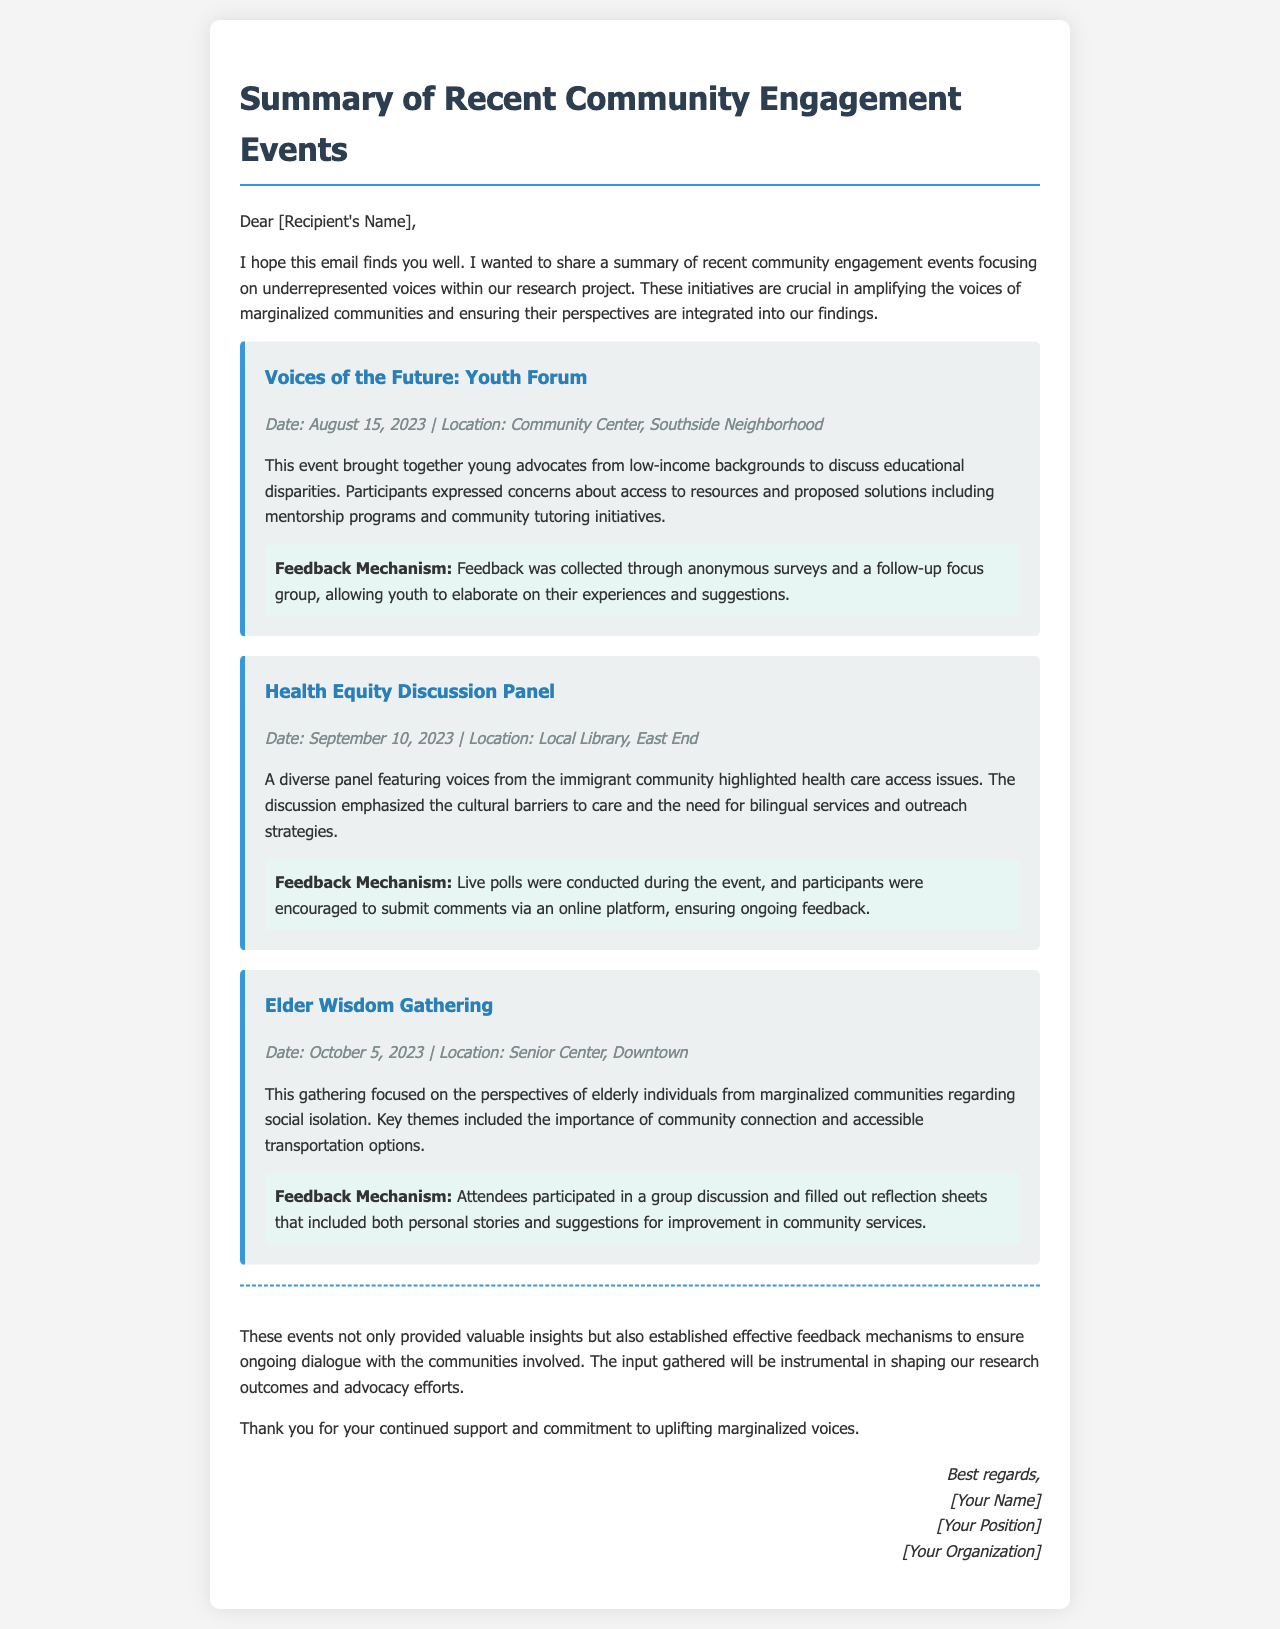What was the date of the Youth Forum? The date of the Youth Forum is specified in the event details.
Answer: August 15, 2023 Where was the Health Equity Discussion Panel held? The location of the Health Equity Discussion Panel is mentioned in the event details.
Answer: Local Library, East End What were the main concerns discussed during the Elder Wisdom Gathering? The key themes discussed during the gathering provide insight into the concerns.
Answer: Social isolation What feedback mechanism was used in the Youth Forum? The document describes the feedback mechanism used during the event.
Answer: Anonymous surveys and a follow-up focus group What is the main aim of the community engagement events mentioned? The introduction of the document outlines the purpose of the events.
Answer: Amplifying the voices of marginalized communities Which community was represented in the Health Equity Discussion Panel? The description of the panel indicates the community represented.
Answer: Immigrant community What kind of insights did the events aim to provide? The conclusion mentions the type of insights gathered from the events.
Answer: Valuable insights How many community engagement events are summarized in the document? The document lists several events, and counting them gives the total.
Answer: Three 